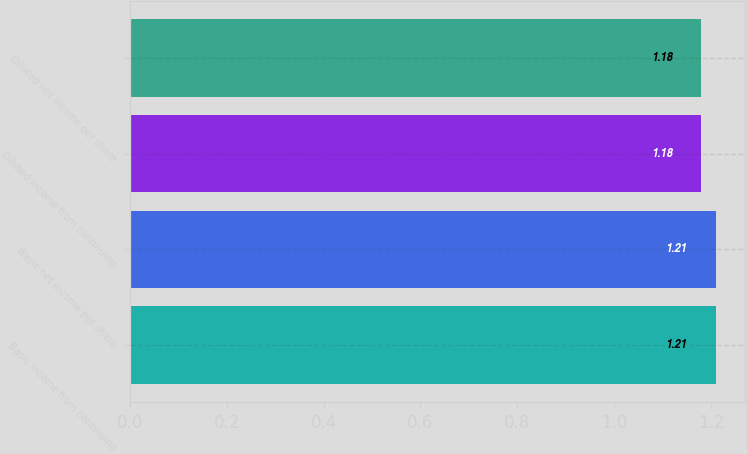<chart> <loc_0><loc_0><loc_500><loc_500><bar_chart><fcel>Basic income from continuing<fcel>Basic net income per share<fcel>Diluted income from continuing<fcel>Diluted net income per share<nl><fcel>1.21<fcel>1.21<fcel>1.18<fcel>1.18<nl></chart> 